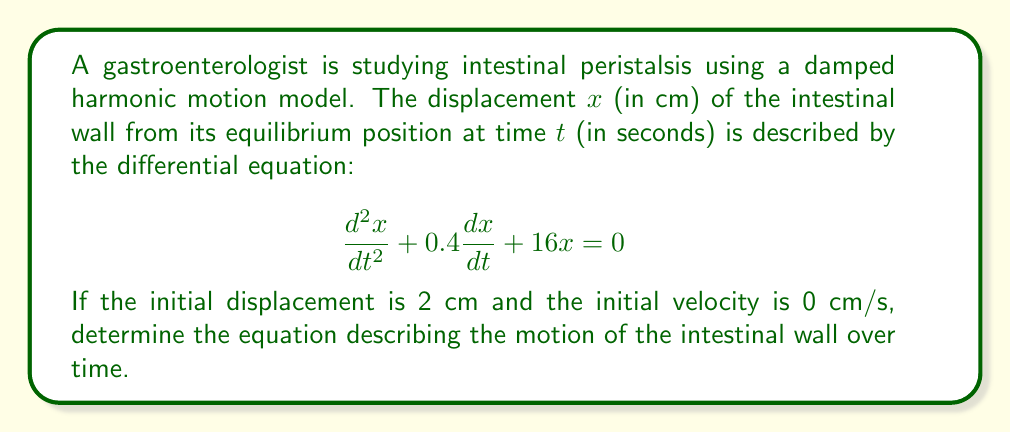Show me your answer to this math problem. To solve this problem, we need to follow these steps:

1) First, we identify this as a second-order linear differential equation with constant coefficients in the form:

   $$\frac{d^2x}{dt^2} + 2\beta\frac{dx}{dt} + \omega_0^2x = 0$$

   Where $2\beta = 0.4$ and $\omega_0^2 = 16$.

2) We need to find the roots of the characteristic equation:

   $$r^2 + 0.4r + 16 = 0$$

3) Using the quadratic formula, $r = \frac{-b \pm \sqrt{b^2 - 4ac}}{2a}$:

   $$r = \frac{-0.4 \pm \sqrt{0.4^2 - 4(1)(16)}}{2(1)} = \frac{-0.4 \pm \sqrt{0.16 - 64}}{2} = \frac{-0.4 \pm \sqrt{-63.84}}{2}$$

4) This gives us complex roots:

   $$r = -0.2 \pm 3.99i$$

5) These roots indicate underdamped motion. The general solution has the form:

   $$x(t) = e^{-\beta t}(A\cos(\omega t) + B\sin(\omega t))$$

   Where $\beta = 0.2$ and $\omega = 3.99$.

6) Using the initial conditions:
   $x(0) = 2$ cm and $x'(0) = 0$ cm/s

7) Applying these conditions:

   $x(0) = A = 2$
   $x'(0) = -0.2A + 3.99B = 0$

8) Solving for B:

   $B = \frac{0.2A}{3.99} = \frac{0.4}{3.99} \approx 0.1$

9) Therefore, the solution is:

   $$x(t) = e^{-0.2t}(2\cos(3.99t) + 0.1\sin(3.99t))$$
Answer: $x(t) = e^{-0.2t}(2\cos(3.99t) + 0.1\sin(3.99t))$ cm 